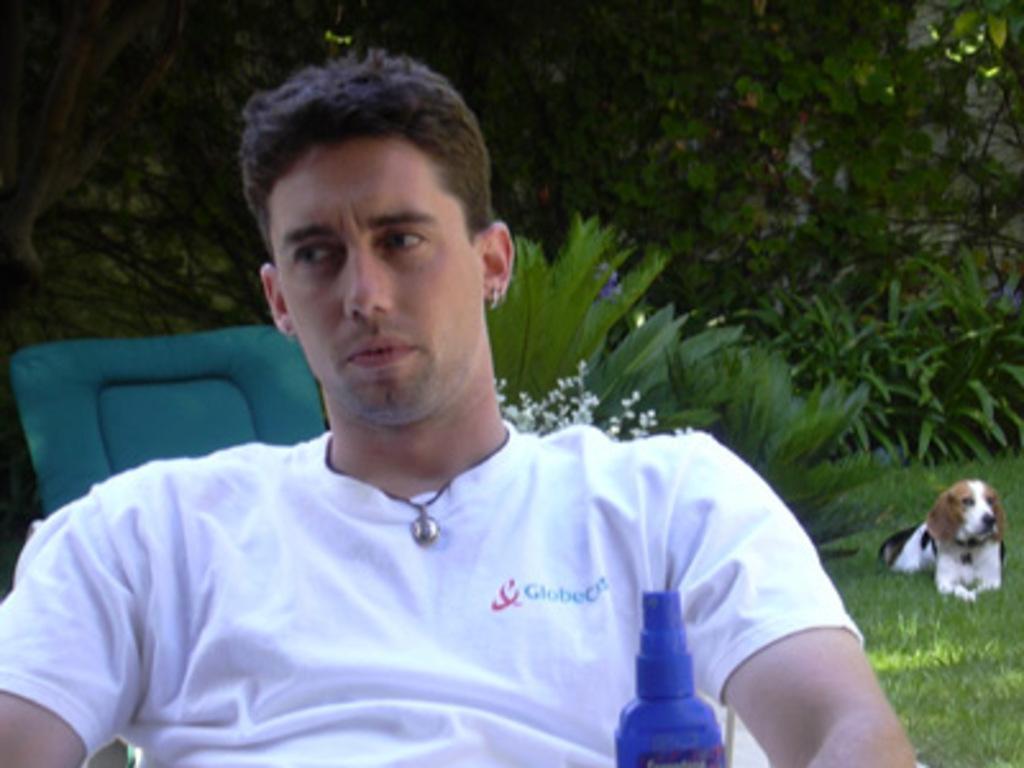How would you summarize this image in a sentence or two? In the center of the image we can see one person is sitting and he is in a white t shirt. In front of him, we can see one blue color object. In the background, we can see trees, plants, grass, one dog, chair and a few other objects. 